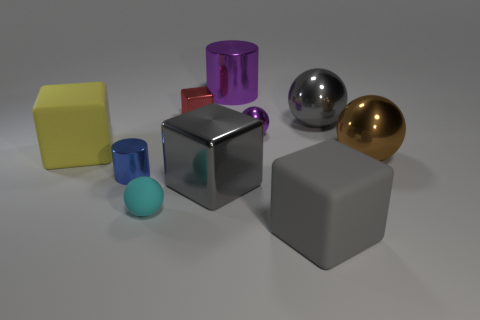Subtract all tiny red cubes. How many cubes are left? 3 Subtract 3 blocks. How many blocks are left? 1 Subtract all gray cubes. How many cubes are left? 2 Subtract all cubes. How many objects are left? 6 Add 10 big green metal balls. How many big green metal balls exist? 10 Subtract 1 gray spheres. How many objects are left? 9 Subtract all brown blocks. Subtract all red spheres. How many blocks are left? 4 Subtract all blue balls. How many blue cylinders are left? 1 Subtract all brown metallic things. Subtract all tiny yellow metallic things. How many objects are left? 9 Add 4 large purple things. How many large purple things are left? 5 